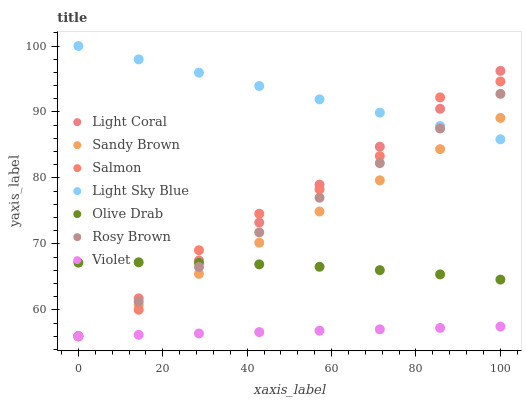Does Violet have the minimum area under the curve?
Answer yes or no. Yes. Does Light Sky Blue have the maximum area under the curve?
Answer yes or no. Yes. Does Salmon have the minimum area under the curve?
Answer yes or no. No. Does Salmon have the maximum area under the curve?
Answer yes or no. No. Is Light Sky Blue the smoothest?
Answer yes or no. Yes. Is Salmon the roughest?
Answer yes or no. Yes. Is Light Coral the smoothest?
Answer yes or no. No. Is Light Coral the roughest?
Answer yes or no. No. Does Rosy Brown have the lowest value?
Answer yes or no. Yes. Does Light Sky Blue have the lowest value?
Answer yes or no. No. Does Light Sky Blue have the highest value?
Answer yes or no. Yes. Does Salmon have the highest value?
Answer yes or no. No. Is Olive Drab less than Light Sky Blue?
Answer yes or no. Yes. Is Light Sky Blue greater than Violet?
Answer yes or no. Yes. Does Rosy Brown intersect Light Coral?
Answer yes or no. Yes. Is Rosy Brown less than Light Coral?
Answer yes or no. No. Is Rosy Brown greater than Light Coral?
Answer yes or no. No. Does Olive Drab intersect Light Sky Blue?
Answer yes or no. No. 